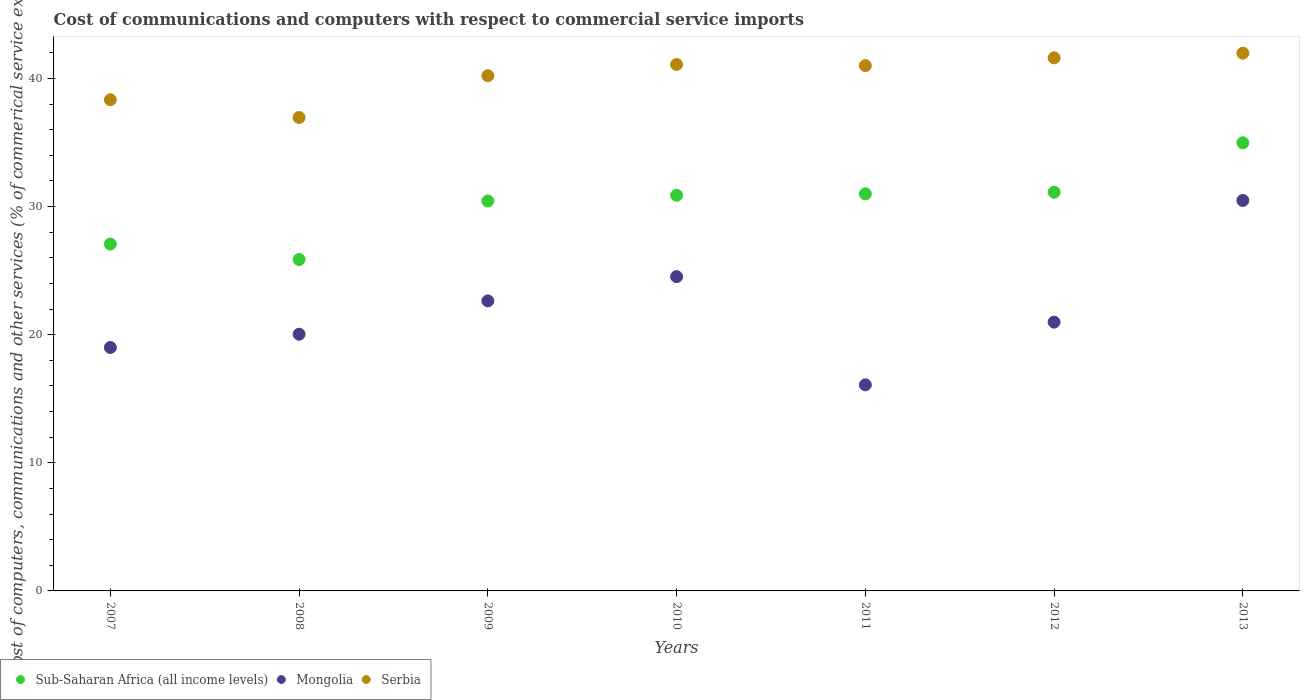Is the number of dotlines equal to the number of legend labels?
Offer a terse response. Yes. What is the cost of communications and computers in Mongolia in 2011?
Your answer should be compact. 16.09. Across all years, what is the maximum cost of communications and computers in Mongolia?
Make the answer very short. 30.48. Across all years, what is the minimum cost of communications and computers in Serbia?
Give a very brief answer. 36.95. In which year was the cost of communications and computers in Sub-Saharan Africa (all income levels) minimum?
Make the answer very short. 2008. What is the total cost of communications and computers in Serbia in the graph?
Your response must be concise. 281.18. What is the difference between the cost of communications and computers in Serbia in 2009 and that in 2013?
Provide a short and direct response. -1.76. What is the difference between the cost of communications and computers in Serbia in 2013 and the cost of communications and computers in Sub-Saharan Africa (all income levels) in 2010?
Make the answer very short. 11.1. What is the average cost of communications and computers in Sub-Saharan Africa (all income levels) per year?
Offer a terse response. 30.19. In the year 2011, what is the difference between the cost of communications and computers in Sub-Saharan Africa (all income levels) and cost of communications and computers in Mongolia?
Provide a short and direct response. 14.9. What is the ratio of the cost of communications and computers in Sub-Saharan Africa (all income levels) in 2008 to that in 2012?
Your answer should be very brief. 0.83. What is the difference between the highest and the second highest cost of communications and computers in Mongolia?
Keep it short and to the point. 5.95. What is the difference between the highest and the lowest cost of communications and computers in Mongolia?
Your response must be concise. 14.39. Is the sum of the cost of communications and computers in Mongolia in 2010 and 2013 greater than the maximum cost of communications and computers in Serbia across all years?
Provide a succinct answer. Yes. Does the cost of communications and computers in Serbia monotonically increase over the years?
Give a very brief answer. No. Is the cost of communications and computers in Mongolia strictly greater than the cost of communications and computers in Sub-Saharan Africa (all income levels) over the years?
Keep it short and to the point. No. Is the cost of communications and computers in Mongolia strictly less than the cost of communications and computers in Sub-Saharan Africa (all income levels) over the years?
Offer a terse response. Yes. Are the values on the major ticks of Y-axis written in scientific E-notation?
Your response must be concise. No. Does the graph contain any zero values?
Provide a succinct answer. No. Does the graph contain grids?
Your response must be concise. No. How many legend labels are there?
Your response must be concise. 3. How are the legend labels stacked?
Make the answer very short. Horizontal. What is the title of the graph?
Provide a short and direct response. Cost of communications and computers with respect to commercial service imports. What is the label or title of the X-axis?
Offer a very short reply. Years. What is the label or title of the Y-axis?
Ensure brevity in your answer.  Cost of computers, communications and other services (% of commerical service exports). What is the Cost of computers, communications and other services (% of commerical service exports) of Sub-Saharan Africa (all income levels) in 2007?
Keep it short and to the point. 27.07. What is the Cost of computers, communications and other services (% of commerical service exports) in Mongolia in 2007?
Offer a terse response. 19. What is the Cost of computers, communications and other services (% of commerical service exports) in Serbia in 2007?
Your answer should be compact. 38.34. What is the Cost of computers, communications and other services (% of commerical service exports) in Sub-Saharan Africa (all income levels) in 2008?
Provide a short and direct response. 25.87. What is the Cost of computers, communications and other services (% of commerical service exports) in Mongolia in 2008?
Ensure brevity in your answer.  20.04. What is the Cost of computers, communications and other services (% of commerical service exports) in Serbia in 2008?
Provide a succinct answer. 36.95. What is the Cost of computers, communications and other services (% of commerical service exports) of Sub-Saharan Africa (all income levels) in 2009?
Provide a succinct answer. 30.43. What is the Cost of computers, communications and other services (% of commerical service exports) of Mongolia in 2009?
Make the answer very short. 22.64. What is the Cost of computers, communications and other services (% of commerical service exports) in Serbia in 2009?
Offer a terse response. 40.21. What is the Cost of computers, communications and other services (% of commerical service exports) in Sub-Saharan Africa (all income levels) in 2010?
Give a very brief answer. 30.88. What is the Cost of computers, communications and other services (% of commerical service exports) of Mongolia in 2010?
Provide a succinct answer. 24.53. What is the Cost of computers, communications and other services (% of commerical service exports) of Serbia in 2010?
Your answer should be compact. 41.09. What is the Cost of computers, communications and other services (% of commerical service exports) in Sub-Saharan Africa (all income levels) in 2011?
Make the answer very short. 30.99. What is the Cost of computers, communications and other services (% of commerical service exports) in Mongolia in 2011?
Your answer should be very brief. 16.09. What is the Cost of computers, communications and other services (% of commerical service exports) of Serbia in 2011?
Offer a very short reply. 41. What is the Cost of computers, communications and other services (% of commerical service exports) in Sub-Saharan Africa (all income levels) in 2012?
Provide a short and direct response. 31.12. What is the Cost of computers, communications and other services (% of commerical service exports) in Mongolia in 2012?
Make the answer very short. 20.98. What is the Cost of computers, communications and other services (% of commerical service exports) in Serbia in 2012?
Your answer should be compact. 41.61. What is the Cost of computers, communications and other services (% of commerical service exports) in Sub-Saharan Africa (all income levels) in 2013?
Provide a succinct answer. 34.98. What is the Cost of computers, communications and other services (% of commerical service exports) in Mongolia in 2013?
Provide a succinct answer. 30.48. What is the Cost of computers, communications and other services (% of commerical service exports) in Serbia in 2013?
Your response must be concise. 41.97. Across all years, what is the maximum Cost of computers, communications and other services (% of commerical service exports) of Sub-Saharan Africa (all income levels)?
Your answer should be very brief. 34.98. Across all years, what is the maximum Cost of computers, communications and other services (% of commerical service exports) in Mongolia?
Keep it short and to the point. 30.48. Across all years, what is the maximum Cost of computers, communications and other services (% of commerical service exports) of Serbia?
Your response must be concise. 41.97. Across all years, what is the minimum Cost of computers, communications and other services (% of commerical service exports) in Sub-Saharan Africa (all income levels)?
Provide a short and direct response. 25.87. Across all years, what is the minimum Cost of computers, communications and other services (% of commerical service exports) in Mongolia?
Your answer should be compact. 16.09. Across all years, what is the minimum Cost of computers, communications and other services (% of commerical service exports) in Serbia?
Keep it short and to the point. 36.95. What is the total Cost of computers, communications and other services (% of commerical service exports) in Sub-Saharan Africa (all income levels) in the graph?
Give a very brief answer. 211.33. What is the total Cost of computers, communications and other services (% of commerical service exports) in Mongolia in the graph?
Give a very brief answer. 153.75. What is the total Cost of computers, communications and other services (% of commerical service exports) in Serbia in the graph?
Your response must be concise. 281.18. What is the difference between the Cost of computers, communications and other services (% of commerical service exports) of Sub-Saharan Africa (all income levels) in 2007 and that in 2008?
Make the answer very short. 1.2. What is the difference between the Cost of computers, communications and other services (% of commerical service exports) of Mongolia in 2007 and that in 2008?
Keep it short and to the point. -1.04. What is the difference between the Cost of computers, communications and other services (% of commerical service exports) in Serbia in 2007 and that in 2008?
Give a very brief answer. 1.38. What is the difference between the Cost of computers, communications and other services (% of commerical service exports) of Sub-Saharan Africa (all income levels) in 2007 and that in 2009?
Your response must be concise. -3.36. What is the difference between the Cost of computers, communications and other services (% of commerical service exports) in Mongolia in 2007 and that in 2009?
Give a very brief answer. -3.64. What is the difference between the Cost of computers, communications and other services (% of commerical service exports) in Serbia in 2007 and that in 2009?
Your answer should be compact. -1.88. What is the difference between the Cost of computers, communications and other services (% of commerical service exports) in Sub-Saharan Africa (all income levels) in 2007 and that in 2010?
Your answer should be very brief. -3.81. What is the difference between the Cost of computers, communications and other services (% of commerical service exports) in Mongolia in 2007 and that in 2010?
Your answer should be compact. -5.53. What is the difference between the Cost of computers, communications and other services (% of commerical service exports) in Serbia in 2007 and that in 2010?
Offer a terse response. -2.75. What is the difference between the Cost of computers, communications and other services (% of commerical service exports) of Sub-Saharan Africa (all income levels) in 2007 and that in 2011?
Provide a succinct answer. -3.92. What is the difference between the Cost of computers, communications and other services (% of commerical service exports) of Mongolia in 2007 and that in 2011?
Provide a short and direct response. 2.91. What is the difference between the Cost of computers, communications and other services (% of commerical service exports) of Serbia in 2007 and that in 2011?
Offer a very short reply. -2.67. What is the difference between the Cost of computers, communications and other services (% of commerical service exports) in Sub-Saharan Africa (all income levels) in 2007 and that in 2012?
Give a very brief answer. -4.05. What is the difference between the Cost of computers, communications and other services (% of commerical service exports) in Mongolia in 2007 and that in 2012?
Your answer should be compact. -1.98. What is the difference between the Cost of computers, communications and other services (% of commerical service exports) of Serbia in 2007 and that in 2012?
Ensure brevity in your answer.  -3.27. What is the difference between the Cost of computers, communications and other services (% of commerical service exports) in Sub-Saharan Africa (all income levels) in 2007 and that in 2013?
Provide a succinct answer. -7.91. What is the difference between the Cost of computers, communications and other services (% of commerical service exports) in Mongolia in 2007 and that in 2013?
Provide a short and direct response. -11.48. What is the difference between the Cost of computers, communications and other services (% of commerical service exports) of Serbia in 2007 and that in 2013?
Keep it short and to the point. -3.64. What is the difference between the Cost of computers, communications and other services (% of commerical service exports) of Sub-Saharan Africa (all income levels) in 2008 and that in 2009?
Provide a short and direct response. -4.56. What is the difference between the Cost of computers, communications and other services (% of commerical service exports) of Mongolia in 2008 and that in 2009?
Keep it short and to the point. -2.6. What is the difference between the Cost of computers, communications and other services (% of commerical service exports) of Serbia in 2008 and that in 2009?
Make the answer very short. -3.26. What is the difference between the Cost of computers, communications and other services (% of commerical service exports) of Sub-Saharan Africa (all income levels) in 2008 and that in 2010?
Your answer should be very brief. -5.01. What is the difference between the Cost of computers, communications and other services (% of commerical service exports) in Mongolia in 2008 and that in 2010?
Keep it short and to the point. -4.49. What is the difference between the Cost of computers, communications and other services (% of commerical service exports) of Serbia in 2008 and that in 2010?
Your answer should be compact. -4.14. What is the difference between the Cost of computers, communications and other services (% of commerical service exports) of Sub-Saharan Africa (all income levels) in 2008 and that in 2011?
Your answer should be compact. -5.12. What is the difference between the Cost of computers, communications and other services (% of commerical service exports) of Mongolia in 2008 and that in 2011?
Offer a terse response. 3.95. What is the difference between the Cost of computers, communications and other services (% of commerical service exports) of Serbia in 2008 and that in 2011?
Give a very brief answer. -4.05. What is the difference between the Cost of computers, communications and other services (% of commerical service exports) of Sub-Saharan Africa (all income levels) in 2008 and that in 2012?
Provide a short and direct response. -5.25. What is the difference between the Cost of computers, communications and other services (% of commerical service exports) in Mongolia in 2008 and that in 2012?
Your response must be concise. -0.94. What is the difference between the Cost of computers, communications and other services (% of commerical service exports) in Serbia in 2008 and that in 2012?
Keep it short and to the point. -4.66. What is the difference between the Cost of computers, communications and other services (% of commerical service exports) of Sub-Saharan Africa (all income levels) in 2008 and that in 2013?
Make the answer very short. -9.11. What is the difference between the Cost of computers, communications and other services (% of commerical service exports) in Mongolia in 2008 and that in 2013?
Ensure brevity in your answer.  -10.44. What is the difference between the Cost of computers, communications and other services (% of commerical service exports) of Serbia in 2008 and that in 2013?
Give a very brief answer. -5.02. What is the difference between the Cost of computers, communications and other services (% of commerical service exports) in Sub-Saharan Africa (all income levels) in 2009 and that in 2010?
Ensure brevity in your answer.  -0.45. What is the difference between the Cost of computers, communications and other services (% of commerical service exports) in Mongolia in 2009 and that in 2010?
Ensure brevity in your answer.  -1.89. What is the difference between the Cost of computers, communications and other services (% of commerical service exports) of Serbia in 2009 and that in 2010?
Provide a short and direct response. -0.88. What is the difference between the Cost of computers, communications and other services (% of commerical service exports) of Sub-Saharan Africa (all income levels) in 2009 and that in 2011?
Your answer should be very brief. -0.56. What is the difference between the Cost of computers, communications and other services (% of commerical service exports) of Mongolia in 2009 and that in 2011?
Your response must be concise. 6.55. What is the difference between the Cost of computers, communications and other services (% of commerical service exports) in Serbia in 2009 and that in 2011?
Keep it short and to the point. -0.79. What is the difference between the Cost of computers, communications and other services (% of commerical service exports) of Sub-Saharan Africa (all income levels) in 2009 and that in 2012?
Your response must be concise. -0.69. What is the difference between the Cost of computers, communications and other services (% of commerical service exports) of Mongolia in 2009 and that in 2012?
Provide a succinct answer. 1.66. What is the difference between the Cost of computers, communications and other services (% of commerical service exports) of Serbia in 2009 and that in 2012?
Give a very brief answer. -1.4. What is the difference between the Cost of computers, communications and other services (% of commerical service exports) of Sub-Saharan Africa (all income levels) in 2009 and that in 2013?
Your answer should be very brief. -4.55. What is the difference between the Cost of computers, communications and other services (% of commerical service exports) of Mongolia in 2009 and that in 2013?
Give a very brief answer. -7.84. What is the difference between the Cost of computers, communications and other services (% of commerical service exports) in Serbia in 2009 and that in 2013?
Ensure brevity in your answer.  -1.76. What is the difference between the Cost of computers, communications and other services (% of commerical service exports) of Sub-Saharan Africa (all income levels) in 2010 and that in 2011?
Offer a terse response. -0.11. What is the difference between the Cost of computers, communications and other services (% of commerical service exports) in Mongolia in 2010 and that in 2011?
Your response must be concise. 8.44. What is the difference between the Cost of computers, communications and other services (% of commerical service exports) of Serbia in 2010 and that in 2011?
Your answer should be very brief. 0.09. What is the difference between the Cost of computers, communications and other services (% of commerical service exports) in Sub-Saharan Africa (all income levels) in 2010 and that in 2012?
Offer a very short reply. -0.24. What is the difference between the Cost of computers, communications and other services (% of commerical service exports) in Mongolia in 2010 and that in 2012?
Make the answer very short. 3.55. What is the difference between the Cost of computers, communications and other services (% of commerical service exports) of Serbia in 2010 and that in 2012?
Provide a short and direct response. -0.52. What is the difference between the Cost of computers, communications and other services (% of commerical service exports) in Sub-Saharan Africa (all income levels) in 2010 and that in 2013?
Make the answer very short. -4.1. What is the difference between the Cost of computers, communications and other services (% of commerical service exports) in Mongolia in 2010 and that in 2013?
Offer a terse response. -5.95. What is the difference between the Cost of computers, communications and other services (% of commerical service exports) in Serbia in 2010 and that in 2013?
Your answer should be very brief. -0.88. What is the difference between the Cost of computers, communications and other services (% of commerical service exports) of Sub-Saharan Africa (all income levels) in 2011 and that in 2012?
Provide a short and direct response. -0.13. What is the difference between the Cost of computers, communications and other services (% of commerical service exports) of Mongolia in 2011 and that in 2012?
Ensure brevity in your answer.  -4.89. What is the difference between the Cost of computers, communications and other services (% of commerical service exports) in Serbia in 2011 and that in 2012?
Your response must be concise. -0.61. What is the difference between the Cost of computers, communications and other services (% of commerical service exports) of Sub-Saharan Africa (all income levels) in 2011 and that in 2013?
Provide a succinct answer. -3.99. What is the difference between the Cost of computers, communications and other services (% of commerical service exports) in Mongolia in 2011 and that in 2013?
Offer a very short reply. -14.39. What is the difference between the Cost of computers, communications and other services (% of commerical service exports) in Serbia in 2011 and that in 2013?
Keep it short and to the point. -0.97. What is the difference between the Cost of computers, communications and other services (% of commerical service exports) of Sub-Saharan Africa (all income levels) in 2012 and that in 2013?
Keep it short and to the point. -3.86. What is the difference between the Cost of computers, communications and other services (% of commerical service exports) of Mongolia in 2012 and that in 2013?
Your response must be concise. -9.5. What is the difference between the Cost of computers, communications and other services (% of commerical service exports) in Serbia in 2012 and that in 2013?
Make the answer very short. -0.36. What is the difference between the Cost of computers, communications and other services (% of commerical service exports) in Sub-Saharan Africa (all income levels) in 2007 and the Cost of computers, communications and other services (% of commerical service exports) in Mongolia in 2008?
Ensure brevity in your answer.  7.04. What is the difference between the Cost of computers, communications and other services (% of commerical service exports) of Sub-Saharan Africa (all income levels) in 2007 and the Cost of computers, communications and other services (% of commerical service exports) of Serbia in 2008?
Your answer should be very brief. -9.88. What is the difference between the Cost of computers, communications and other services (% of commerical service exports) in Mongolia in 2007 and the Cost of computers, communications and other services (% of commerical service exports) in Serbia in 2008?
Provide a short and direct response. -17.95. What is the difference between the Cost of computers, communications and other services (% of commerical service exports) in Sub-Saharan Africa (all income levels) in 2007 and the Cost of computers, communications and other services (% of commerical service exports) in Mongolia in 2009?
Offer a terse response. 4.43. What is the difference between the Cost of computers, communications and other services (% of commerical service exports) of Sub-Saharan Africa (all income levels) in 2007 and the Cost of computers, communications and other services (% of commerical service exports) of Serbia in 2009?
Make the answer very short. -13.14. What is the difference between the Cost of computers, communications and other services (% of commerical service exports) of Mongolia in 2007 and the Cost of computers, communications and other services (% of commerical service exports) of Serbia in 2009?
Your response must be concise. -21.21. What is the difference between the Cost of computers, communications and other services (% of commerical service exports) in Sub-Saharan Africa (all income levels) in 2007 and the Cost of computers, communications and other services (% of commerical service exports) in Mongolia in 2010?
Offer a terse response. 2.54. What is the difference between the Cost of computers, communications and other services (% of commerical service exports) in Sub-Saharan Africa (all income levels) in 2007 and the Cost of computers, communications and other services (% of commerical service exports) in Serbia in 2010?
Your answer should be compact. -14.02. What is the difference between the Cost of computers, communications and other services (% of commerical service exports) in Mongolia in 2007 and the Cost of computers, communications and other services (% of commerical service exports) in Serbia in 2010?
Provide a short and direct response. -22.09. What is the difference between the Cost of computers, communications and other services (% of commerical service exports) of Sub-Saharan Africa (all income levels) in 2007 and the Cost of computers, communications and other services (% of commerical service exports) of Mongolia in 2011?
Your answer should be compact. 10.98. What is the difference between the Cost of computers, communications and other services (% of commerical service exports) in Sub-Saharan Africa (all income levels) in 2007 and the Cost of computers, communications and other services (% of commerical service exports) in Serbia in 2011?
Ensure brevity in your answer.  -13.93. What is the difference between the Cost of computers, communications and other services (% of commerical service exports) in Mongolia in 2007 and the Cost of computers, communications and other services (% of commerical service exports) in Serbia in 2011?
Ensure brevity in your answer.  -22. What is the difference between the Cost of computers, communications and other services (% of commerical service exports) of Sub-Saharan Africa (all income levels) in 2007 and the Cost of computers, communications and other services (% of commerical service exports) of Mongolia in 2012?
Your answer should be very brief. 6.09. What is the difference between the Cost of computers, communications and other services (% of commerical service exports) in Sub-Saharan Africa (all income levels) in 2007 and the Cost of computers, communications and other services (% of commerical service exports) in Serbia in 2012?
Offer a very short reply. -14.54. What is the difference between the Cost of computers, communications and other services (% of commerical service exports) of Mongolia in 2007 and the Cost of computers, communications and other services (% of commerical service exports) of Serbia in 2012?
Keep it short and to the point. -22.61. What is the difference between the Cost of computers, communications and other services (% of commerical service exports) in Sub-Saharan Africa (all income levels) in 2007 and the Cost of computers, communications and other services (% of commerical service exports) in Mongolia in 2013?
Make the answer very short. -3.41. What is the difference between the Cost of computers, communications and other services (% of commerical service exports) of Sub-Saharan Africa (all income levels) in 2007 and the Cost of computers, communications and other services (% of commerical service exports) of Serbia in 2013?
Keep it short and to the point. -14.9. What is the difference between the Cost of computers, communications and other services (% of commerical service exports) of Mongolia in 2007 and the Cost of computers, communications and other services (% of commerical service exports) of Serbia in 2013?
Provide a succinct answer. -22.97. What is the difference between the Cost of computers, communications and other services (% of commerical service exports) of Sub-Saharan Africa (all income levels) in 2008 and the Cost of computers, communications and other services (% of commerical service exports) of Mongolia in 2009?
Give a very brief answer. 3.23. What is the difference between the Cost of computers, communications and other services (% of commerical service exports) in Sub-Saharan Africa (all income levels) in 2008 and the Cost of computers, communications and other services (% of commerical service exports) in Serbia in 2009?
Offer a terse response. -14.35. What is the difference between the Cost of computers, communications and other services (% of commerical service exports) of Mongolia in 2008 and the Cost of computers, communications and other services (% of commerical service exports) of Serbia in 2009?
Ensure brevity in your answer.  -20.18. What is the difference between the Cost of computers, communications and other services (% of commerical service exports) of Sub-Saharan Africa (all income levels) in 2008 and the Cost of computers, communications and other services (% of commerical service exports) of Mongolia in 2010?
Keep it short and to the point. 1.34. What is the difference between the Cost of computers, communications and other services (% of commerical service exports) in Sub-Saharan Africa (all income levels) in 2008 and the Cost of computers, communications and other services (% of commerical service exports) in Serbia in 2010?
Your response must be concise. -15.22. What is the difference between the Cost of computers, communications and other services (% of commerical service exports) of Mongolia in 2008 and the Cost of computers, communications and other services (% of commerical service exports) of Serbia in 2010?
Your answer should be very brief. -21.06. What is the difference between the Cost of computers, communications and other services (% of commerical service exports) of Sub-Saharan Africa (all income levels) in 2008 and the Cost of computers, communications and other services (% of commerical service exports) of Mongolia in 2011?
Your answer should be compact. 9.78. What is the difference between the Cost of computers, communications and other services (% of commerical service exports) of Sub-Saharan Africa (all income levels) in 2008 and the Cost of computers, communications and other services (% of commerical service exports) of Serbia in 2011?
Your answer should be very brief. -15.14. What is the difference between the Cost of computers, communications and other services (% of commerical service exports) of Mongolia in 2008 and the Cost of computers, communications and other services (% of commerical service exports) of Serbia in 2011?
Your answer should be compact. -20.97. What is the difference between the Cost of computers, communications and other services (% of commerical service exports) of Sub-Saharan Africa (all income levels) in 2008 and the Cost of computers, communications and other services (% of commerical service exports) of Mongolia in 2012?
Your answer should be compact. 4.89. What is the difference between the Cost of computers, communications and other services (% of commerical service exports) of Sub-Saharan Africa (all income levels) in 2008 and the Cost of computers, communications and other services (% of commerical service exports) of Serbia in 2012?
Ensure brevity in your answer.  -15.74. What is the difference between the Cost of computers, communications and other services (% of commerical service exports) in Mongolia in 2008 and the Cost of computers, communications and other services (% of commerical service exports) in Serbia in 2012?
Your response must be concise. -21.57. What is the difference between the Cost of computers, communications and other services (% of commerical service exports) in Sub-Saharan Africa (all income levels) in 2008 and the Cost of computers, communications and other services (% of commerical service exports) in Mongolia in 2013?
Offer a terse response. -4.61. What is the difference between the Cost of computers, communications and other services (% of commerical service exports) in Sub-Saharan Africa (all income levels) in 2008 and the Cost of computers, communications and other services (% of commerical service exports) in Serbia in 2013?
Your answer should be compact. -16.11. What is the difference between the Cost of computers, communications and other services (% of commerical service exports) of Mongolia in 2008 and the Cost of computers, communications and other services (% of commerical service exports) of Serbia in 2013?
Give a very brief answer. -21.94. What is the difference between the Cost of computers, communications and other services (% of commerical service exports) in Sub-Saharan Africa (all income levels) in 2009 and the Cost of computers, communications and other services (% of commerical service exports) in Mongolia in 2010?
Your answer should be compact. 5.9. What is the difference between the Cost of computers, communications and other services (% of commerical service exports) of Sub-Saharan Africa (all income levels) in 2009 and the Cost of computers, communications and other services (% of commerical service exports) of Serbia in 2010?
Keep it short and to the point. -10.66. What is the difference between the Cost of computers, communications and other services (% of commerical service exports) of Mongolia in 2009 and the Cost of computers, communications and other services (% of commerical service exports) of Serbia in 2010?
Provide a succinct answer. -18.45. What is the difference between the Cost of computers, communications and other services (% of commerical service exports) of Sub-Saharan Africa (all income levels) in 2009 and the Cost of computers, communications and other services (% of commerical service exports) of Mongolia in 2011?
Give a very brief answer. 14.35. What is the difference between the Cost of computers, communications and other services (% of commerical service exports) in Sub-Saharan Africa (all income levels) in 2009 and the Cost of computers, communications and other services (% of commerical service exports) in Serbia in 2011?
Offer a terse response. -10.57. What is the difference between the Cost of computers, communications and other services (% of commerical service exports) in Mongolia in 2009 and the Cost of computers, communications and other services (% of commerical service exports) in Serbia in 2011?
Your response must be concise. -18.37. What is the difference between the Cost of computers, communications and other services (% of commerical service exports) of Sub-Saharan Africa (all income levels) in 2009 and the Cost of computers, communications and other services (% of commerical service exports) of Mongolia in 2012?
Your answer should be compact. 9.45. What is the difference between the Cost of computers, communications and other services (% of commerical service exports) in Sub-Saharan Africa (all income levels) in 2009 and the Cost of computers, communications and other services (% of commerical service exports) in Serbia in 2012?
Keep it short and to the point. -11.18. What is the difference between the Cost of computers, communications and other services (% of commerical service exports) of Mongolia in 2009 and the Cost of computers, communications and other services (% of commerical service exports) of Serbia in 2012?
Keep it short and to the point. -18.97. What is the difference between the Cost of computers, communications and other services (% of commerical service exports) of Sub-Saharan Africa (all income levels) in 2009 and the Cost of computers, communications and other services (% of commerical service exports) of Mongolia in 2013?
Provide a short and direct response. -0.05. What is the difference between the Cost of computers, communications and other services (% of commerical service exports) of Sub-Saharan Africa (all income levels) in 2009 and the Cost of computers, communications and other services (% of commerical service exports) of Serbia in 2013?
Give a very brief answer. -11.54. What is the difference between the Cost of computers, communications and other services (% of commerical service exports) in Mongolia in 2009 and the Cost of computers, communications and other services (% of commerical service exports) in Serbia in 2013?
Ensure brevity in your answer.  -19.34. What is the difference between the Cost of computers, communications and other services (% of commerical service exports) of Sub-Saharan Africa (all income levels) in 2010 and the Cost of computers, communications and other services (% of commerical service exports) of Mongolia in 2011?
Provide a short and direct response. 14.79. What is the difference between the Cost of computers, communications and other services (% of commerical service exports) of Sub-Saharan Africa (all income levels) in 2010 and the Cost of computers, communications and other services (% of commerical service exports) of Serbia in 2011?
Give a very brief answer. -10.13. What is the difference between the Cost of computers, communications and other services (% of commerical service exports) in Mongolia in 2010 and the Cost of computers, communications and other services (% of commerical service exports) in Serbia in 2011?
Your response must be concise. -16.47. What is the difference between the Cost of computers, communications and other services (% of commerical service exports) in Sub-Saharan Africa (all income levels) in 2010 and the Cost of computers, communications and other services (% of commerical service exports) in Mongolia in 2012?
Your answer should be compact. 9.9. What is the difference between the Cost of computers, communications and other services (% of commerical service exports) of Sub-Saharan Africa (all income levels) in 2010 and the Cost of computers, communications and other services (% of commerical service exports) of Serbia in 2012?
Ensure brevity in your answer.  -10.73. What is the difference between the Cost of computers, communications and other services (% of commerical service exports) of Mongolia in 2010 and the Cost of computers, communications and other services (% of commerical service exports) of Serbia in 2012?
Offer a very short reply. -17.08. What is the difference between the Cost of computers, communications and other services (% of commerical service exports) of Sub-Saharan Africa (all income levels) in 2010 and the Cost of computers, communications and other services (% of commerical service exports) of Mongolia in 2013?
Make the answer very short. 0.4. What is the difference between the Cost of computers, communications and other services (% of commerical service exports) in Sub-Saharan Africa (all income levels) in 2010 and the Cost of computers, communications and other services (% of commerical service exports) in Serbia in 2013?
Provide a succinct answer. -11.1. What is the difference between the Cost of computers, communications and other services (% of commerical service exports) of Mongolia in 2010 and the Cost of computers, communications and other services (% of commerical service exports) of Serbia in 2013?
Provide a short and direct response. -17.44. What is the difference between the Cost of computers, communications and other services (% of commerical service exports) of Sub-Saharan Africa (all income levels) in 2011 and the Cost of computers, communications and other services (% of commerical service exports) of Mongolia in 2012?
Your answer should be compact. 10.01. What is the difference between the Cost of computers, communications and other services (% of commerical service exports) in Sub-Saharan Africa (all income levels) in 2011 and the Cost of computers, communications and other services (% of commerical service exports) in Serbia in 2012?
Offer a terse response. -10.62. What is the difference between the Cost of computers, communications and other services (% of commerical service exports) of Mongolia in 2011 and the Cost of computers, communications and other services (% of commerical service exports) of Serbia in 2012?
Your answer should be compact. -25.52. What is the difference between the Cost of computers, communications and other services (% of commerical service exports) in Sub-Saharan Africa (all income levels) in 2011 and the Cost of computers, communications and other services (% of commerical service exports) in Mongolia in 2013?
Ensure brevity in your answer.  0.51. What is the difference between the Cost of computers, communications and other services (% of commerical service exports) in Sub-Saharan Africa (all income levels) in 2011 and the Cost of computers, communications and other services (% of commerical service exports) in Serbia in 2013?
Your answer should be compact. -10.98. What is the difference between the Cost of computers, communications and other services (% of commerical service exports) of Mongolia in 2011 and the Cost of computers, communications and other services (% of commerical service exports) of Serbia in 2013?
Offer a very short reply. -25.89. What is the difference between the Cost of computers, communications and other services (% of commerical service exports) of Sub-Saharan Africa (all income levels) in 2012 and the Cost of computers, communications and other services (% of commerical service exports) of Mongolia in 2013?
Give a very brief answer. 0.64. What is the difference between the Cost of computers, communications and other services (% of commerical service exports) of Sub-Saharan Africa (all income levels) in 2012 and the Cost of computers, communications and other services (% of commerical service exports) of Serbia in 2013?
Provide a succinct answer. -10.85. What is the difference between the Cost of computers, communications and other services (% of commerical service exports) of Mongolia in 2012 and the Cost of computers, communications and other services (% of commerical service exports) of Serbia in 2013?
Your answer should be very brief. -20.99. What is the average Cost of computers, communications and other services (% of commerical service exports) in Sub-Saharan Africa (all income levels) per year?
Offer a very short reply. 30.19. What is the average Cost of computers, communications and other services (% of commerical service exports) of Mongolia per year?
Keep it short and to the point. 21.96. What is the average Cost of computers, communications and other services (% of commerical service exports) in Serbia per year?
Offer a very short reply. 40.17. In the year 2007, what is the difference between the Cost of computers, communications and other services (% of commerical service exports) of Sub-Saharan Africa (all income levels) and Cost of computers, communications and other services (% of commerical service exports) of Mongolia?
Provide a short and direct response. 8.07. In the year 2007, what is the difference between the Cost of computers, communications and other services (% of commerical service exports) in Sub-Saharan Africa (all income levels) and Cost of computers, communications and other services (% of commerical service exports) in Serbia?
Provide a succinct answer. -11.27. In the year 2007, what is the difference between the Cost of computers, communications and other services (% of commerical service exports) of Mongolia and Cost of computers, communications and other services (% of commerical service exports) of Serbia?
Offer a terse response. -19.34. In the year 2008, what is the difference between the Cost of computers, communications and other services (% of commerical service exports) in Sub-Saharan Africa (all income levels) and Cost of computers, communications and other services (% of commerical service exports) in Mongolia?
Provide a succinct answer. 5.83. In the year 2008, what is the difference between the Cost of computers, communications and other services (% of commerical service exports) in Sub-Saharan Africa (all income levels) and Cost of computers, communications and other services (% of commerical service exports) in Serbia?
Make the answer very short. -11.08. In the year 2008, what is the difference between the Cost of computers, communications and other services (% of commerical service exports) in Mongolia and Cost of computers, communications and other services (% of commerical service exports) in Serbia?
Provide a succinct answer. -16.92. In the year 2009, what is the difference between the Cost of computers, communications and other services (% of commerical service exports) of Sub-Saharan Africa (all income levels) and Cost of computers, communications and other services (% of commerical service exports) of Mongolia?
Your answer should be compact. 7.8. In the year 2009, what is the difference between the Cost of computers, communications and other services (% of commerical service exports) of Sub-Saharan Africa (all income levels) and Cost of computers, communications and other services (% of commerical service exports) of Serbia?
Keep it short and to the point. -9.78. In the year 2009, what is the difference between the Cost of computers, communications and other services (% of commerical service exports) in Mongolia and Cost of computers, communications and other services (% of commerical service exports) in Serbia?
Give a very brief answer. -17.58. In the year 2010, what is the difference between the Cost of computers, communications and other services (% of commerical service exports) in Sub-Saharan Africa (all income levels) and Cost of computers, communications and other services (% of commerical service exports) in Mongolia?
Make the answer very short. 6.35. In the year 2010, what is the difference between the Cost of computers, communications and other services (% of commerical service exports) of Sub-Saharan Africa (all income levels) and Cost of computers, communications and other services (% of commerical service exports) of Serbia?
Provide a short and direct response. -10.21. In the year 2010, what is the difference between the Cost of computers, communications and other services (% of commerical service exports) in Mongolia and Cost of computers, communications and other services (% of commerical service exports) in Serbia?
Keep it short and to the point. -16.56. In the year 2011, what is the difference between the Cost of computers, communications and other services (% of commerical service exports) in Sub-Saharan Africa (all income levels) and Cost of computers, communications and other services (% of commerical service exports) in Mongolia?
Make the answer very short. 14.9. In the year 2011, what is the difference between the Cost of computers, communications and other services (% of commerical service exports) of Sub-Saharan Africa (all income levels) and Cost of computers, communications and other services (% of commerical service exports) of Serbia?
Your response must be concise. -10.01. In the year 2011, what is the difference between the Cost of computers, communications and other services (% of commerical service exports) in Mongolia and Cost of computers, communications and other services (% of commerical service exports) in Serbia?
Your answer should be compact. -24.92. In the year 2012, what is the difference between the Cost of computers, communications and other services (% of commerical service exports) in Sub-Saharan Africa (all income levels) and Cost of computers, communications and other services (% of commerical service exports) in Mongolia?
Your response must be concise. 10.14. In the year 2012, what is the difference between the Cost of computers, communications and other services (% of commerical service exports) of Sub-Saharan Africa (all income levels) and Cost of computers, communications and other services (% of commerical service exports) of Serbia?
Ensure brevity in your answer.  -10.49. In the year 2012, what is the difference between the Cost of computers, communications and other services (% of commerical service exports) of Mongolia and Cost of computers, communications and other services (% of commerical service exports) of Serbia?
Your answer should be compact. -20.63. In the year 2013, what is the difference between the Cost of computers, communications and other services (% of commerical service exports) of Sub-Saharan Africa (all income levels) and Cost of computers, communications and other services (% of commerical service exports) of Mongolia?
Offer a very short reply. 4.5. In the year 2013, what is the difference between the Cost of computers, communications and other services (% of commerical service exports) in Sub-Saharan Africa (all income levels) and Cost of computers, communications and other services (% of commerical service exports) in Serbia?
Provide a succinct answer. -7. In the year 2013, what is the difference between the Cost of computers, communications and other services (% of commerical service exports) in Mongolia and Cost of computers, communications and other services (% of commerical service exports) in Serbia?
Your answer should be very brief. -11.49. What is the ratio of the Cost of computers, communications and other services (% of commerical service exports) in Sub-Saharan Africa (all income levels) in 2007 to that in 2008?
Make the answer very short. 1.05. What is the ratio of the Cost of computers, communications and other services (% of commerical service exports) of Mongolia in 2007 to that in 2008?
Your answer should be very brief. 0.95. What is the ratio of the Cost of computers, communications and other services (% of commerical service exports) of Serbia in 2007 to that in 2008?
Offer a very short reply. 1.04. What is the ratio of the Cost of computers, communications and other services (% of commerical service exports) in Sub-Saharan Africa (all income levels) in 2007 to that in 2009?
Give a very brief answer. 0.89. What is the ratio of the Cost of computers, communications and other services (% of commerical service exports) of Mongolia in 2007 to that in 2009?
Make the answer very short. 0.84. What is the ratio of the Cost of computers, communications and other services (% of commerical service exports) of Serbia in 2007 to that in 2009?
Offer a very short reply. 0.95. What is the ratio of the Cost of computers, communications and other services (% of commerical service exports) in Sub-Saharan Africa (all income levels) in 2007 to that in 2010?
Keep it short and to the point. 0.88. What is the ratio of the Cost of computers, communications and other services (% of commerical service exports) of Mongolia in 2007 to that in 2010?
Offer a terse response. 0.77. What is the ratio of the Cost of computers, communications and other services (% of commerical service exports) of Serbia in 2007 to that in 2010?
Keep it short and to the point. 0.93. What is the ratio of the Cost of computers, communications and other services (% of commerical service exports) of Sub-Saharan Africa (all income levels) in 2007 to that in 2011?
Keep it short and to the point. 0.87. What is the ratio of the Cost of computers, communications and other services (% of commerical service exports) of Mongolia in 2007 to that in 2011?
Your answer should be very brief. 1.18. What is the ratio of the Cost of computers, communications and other services (% of commerical service exports) of Serbia in 2007 to that in 2011?
Offer a terse response. 0.93. What is the ratio of the Cost of computers, communications and other services (% of commerical service exports) in Sub-Saharan Africa (all income levels) in 2007 to that in 2012?
Ensure brevity in your answer.  0.87. What is the ratio of the Cost of computers, communications and other services (% of commerical service exports) of Mongolia in 2007 to that in 2012?
Your answer should be very brief. 0.91. What is the ratio of the Cost of computers, communications and other services (% of commerical service exports) of Serbia in 2007 to that in 2012?
Offer a very short reply. 0.92. What is the ratio of the Cost of computers, communications and other services (% of commerical service exports) of Sub-Saharan Africa (all income levels) in 2007 to that in 2013?
Your response must be concise. 0.77. What is the ratio of the Cost of computers, communications and other services (% of commerical service exports) in Mongolia in 2007 to that in 2013?
Make the answer very short. 0.62. What is the ratio of the Cost of computers, communications and other services (% of commerical service exports) in Serbia in 2007 to that in 2013?
Provide a short and direct response. 0.91. What is the ratio of the Cost of computers, communications and other services (% of commerical service exports) in Sub-Saharan Africa (all income levels) in 2008 to that in 2009?
Offer a terse response. 0.85. What is the ratio of the Cost of computers, communications and other services (% of commerical service exports) in Mongolia in 2008 to that in 2009?
Your answer should be compact. 0.89. What is the ratio of the Cost of computers, communications and other services (% of commerical service exports) of Serbia in 2008 to that in 2009?
Give a very brief answer. 0.92. What is the ratio of the Cost of computers, communications and other services (% of commerical service exports) in Sub-Saharan Africa (all income levels) in 2008 to that in 2010?
Your response must be concise. 0.84. What is the ratio of the Cost of computers, communications and other services (% of commerical service exports) in Mongolia in 2008 to that in 2010?
Ensure brevity in your answer.  0.82. What is the ratio of the Cost of computers, communications and other services (% of commerical service exports) in Serbia in 2008 to that in 2010?
Your response must be concise. 0.9. What is the ratio of the Cost of computers, communications and other services (% of commerical service exports) in Sub-Saharan Africa (all income levels) in 2008 to that in 2011?
Keep it short and to the point. 0.83. What is the ratio of the Cost of computers, communications and other services (% of commerical service exports) of Mongolia in 2008 to that in 2011?
Your response must be concise. 1.25. What is the ratio of the Cost of computers, communications and other services (% of commerical service exports) in Serbia in 2008 to that in 2011?
Keep it short and to the point. 0.9. What is the ratio of the Cost of computers, communications and other services (% of commerical service exports) of Sub-Saharan Africa (all income levels) in 2008 to that in 2012?
Offer a terse response. 0.83. What is the ratio of the Cost of computers, communications and other services (% of commerical service exports) of Mongolia in 2008 to that in 2012?
Offer a very short reply. 0.96. What is the ratio of the Cost of computers, communications and other services (% of commerical service exports) in Serbia in 2008 to that in 2012?
Give a very brief answer. 0.89. What is the ratio of the Cost of computers, communications and other services (% of commerical service exports) in Sub-Saharan Africa (all income levels) in 2008 to that in 2013?
Make the answer very short. 0.74. What is the ratio of the Cost of computers, communications and other services (% of commerical service exports) in Mongolia in 2008 to that in 2013?
Provide a succinct answer. 0.66. What is the ratio of the Cost of computers, communications and other services (% of commerical service exports) of Serbia in 2008 to that in 2013?
Your answer should be compact. 0.88. What is the ratio of the Cost of computers, communications and other services (% of commerical service exports) in Sub-Saharan Africa (all income levels) in 2009 to that in 2010?
Provide a succinct answer. 0.99. What is the ratio of the Cost of computers, communications and other services (% of commerical service exports) in Mongolia in 2009 to that in 2010?
Ensure brevity in your answer.  0.92. What is the ratio of the Cost of computers, communications and other services (% of commerical service exports) in Serbia in 2009 to that in 2010?
Give a very brief answer. 0.98. What is the ratio of the Cost of computers, communications and other services (% of commerical service exports) in Mongolia in 2009 to that in 2011?
Offer a terse response. 1.41. What is the ratio of the Cost of computers, communications and other services (% of commerical service exports) of Serbia in 2009 to that in 2011?
Make the answer very short. 0.98. What is the ratio of the Cost of computers, communications and other services (% of commerical service exports) in Sub-Saharan Africa (all income levels) in 2009 to that in 2012?
Make the answer very short. 0.98. What is the ratio of the Cost of computers, communications and other services (% of commerical service exports) in Mongolia in 2009 to that in 2012?
Give a very brief answer. 1.08. What is the ratio of the Cost of computers, communications and other services (% of commerical service exports) in Serbia in 2009 to that in 2012?
Your response must be concise. 0.97. What is the ratio of the Cost of computers, communications and other services (% of commerical service exports) in Sub-Saharan Africa (all income levels) in 2009 to that in 2013?
Your answer should be very brief. 0.87. What is the ratio of the Cost of computers, communications and other services (% of commerical service exports) in Mongolia in 2009 to that in 2013?
Offer a terse response. 0.74. What is the ratio of the Cost of computers, communications and other services (% of commerical service exports) in Serbia in 2009 to that in 2013?
Give a very brief answer. 0.96. What is the ratio of the Cost of computers, communications and other services (% of commerical service exports) in Mongolia in 2010 to that in 2011?
Offer a terse response. 1.52. What is the ratio of the Cost of computers, communications and other services (% of commerical service exports) of Mongolia in 2010 to that in 2012?
Keep it short and to the point. 1.17. What is the ratio of the Cost of computers, communications and other services (% of commerical service exports) in Serbia in 2010 to that in 2012?
Offer a terse response. 0.99. What is the ratio of the Cost of computers, communications and other services (% of commerical service exports) in Sub-Saharan Africa (all income levels) in 2010 to that in 2013?
Your answer should be very brief. 0.88. What is the ratio of the Cost of computers, communications and other services (% of commerical service exports) of Mongolia in 2010 to that in 2013?
Provide a succinct answer. 0.8. What is the ratio of the Cost of computers, communications and other services (% of commerical service exports) in Serbia in 2010 to that in 2013?
Ensure brevity in your answer.  0.98. What is the ratio of the Cost of computers, communications and other services (% of commerical service exports) of Sub-Saharan Africa (all income levels) in 2011 to that in 2012?
Offer a very short reply. 1. What is the ratio of the Cost of computers, communications and other services (% of commerical service exports) of Mongolia in 2011 to that in 2012?
Offer a very short reply. 0.77. What is the ratio of the Cost of computers, communications and other services (% of commerical service exports) in Serbia in 2011 to that in 2012?
Provide a short and direct response. 0.99. What is the ratio of the Cost of computers, communications and other services (% of commerical service exports) of Sub-Saharan Africa (all income levels) in 2011 to that in 2013?
Ensure brevity in your answer.  0.89. What is the ratio of the Cost of computers, communications and other services (% of commerical service exports) in Mongolia in 2011 to that in 2013?
Offer a terse response. 0.53. What is the ratio of the Cost of computers, communications and other services (% of commerical service exports) in Serbia in 2011 to that in 2013?
Make the answer very short. 0.98. What is the ratio of the Cost of computers, communications and other services (% of commerical service exports) of Sub-Saharan Africa (all income levels) in 2012 to that in 2013?
Your answer should be compact. 0.89. What is the ratio of the Cost of computers, communications and other services (% of commerical service exports) in Mongolia in 2012 to that in 2013?
Your answer should be compact. 0.69. What is the difference between the highest and the second highest Cost of computers, communications and other services (% of commerical service exports) in Sub-Saharan Africa (all income levels)?
Give a very brief answer. 3.86. What is the difference between the highest and the second highest Cost of computers, communications and other services (% of commerical service exports) in Mongolia?
Offer a very short reply. 5.95. What is the difference between the highest and the second highest Cost of computers, communications and other services (% of commerical service exports) of Serbia?
Make the answer very short. 0.36. What is the difference between the highest and the lowest Cost of computers, communications and other services (% of commerical service exports) in Sub-Saharan Africa (all income levels)?
Give a very brief answer. 9.11. What is the difference between the highest and the lowest Cost of computers, communications and other services (% of commerical service exports) in Mongolia?
Your answer should be compact. 14.39. What is the difference between the highest and the lowest Cost of computers, communications and other services (% of commerical service exports) of Serbia?
Provide a succinct answer. 5.02. 